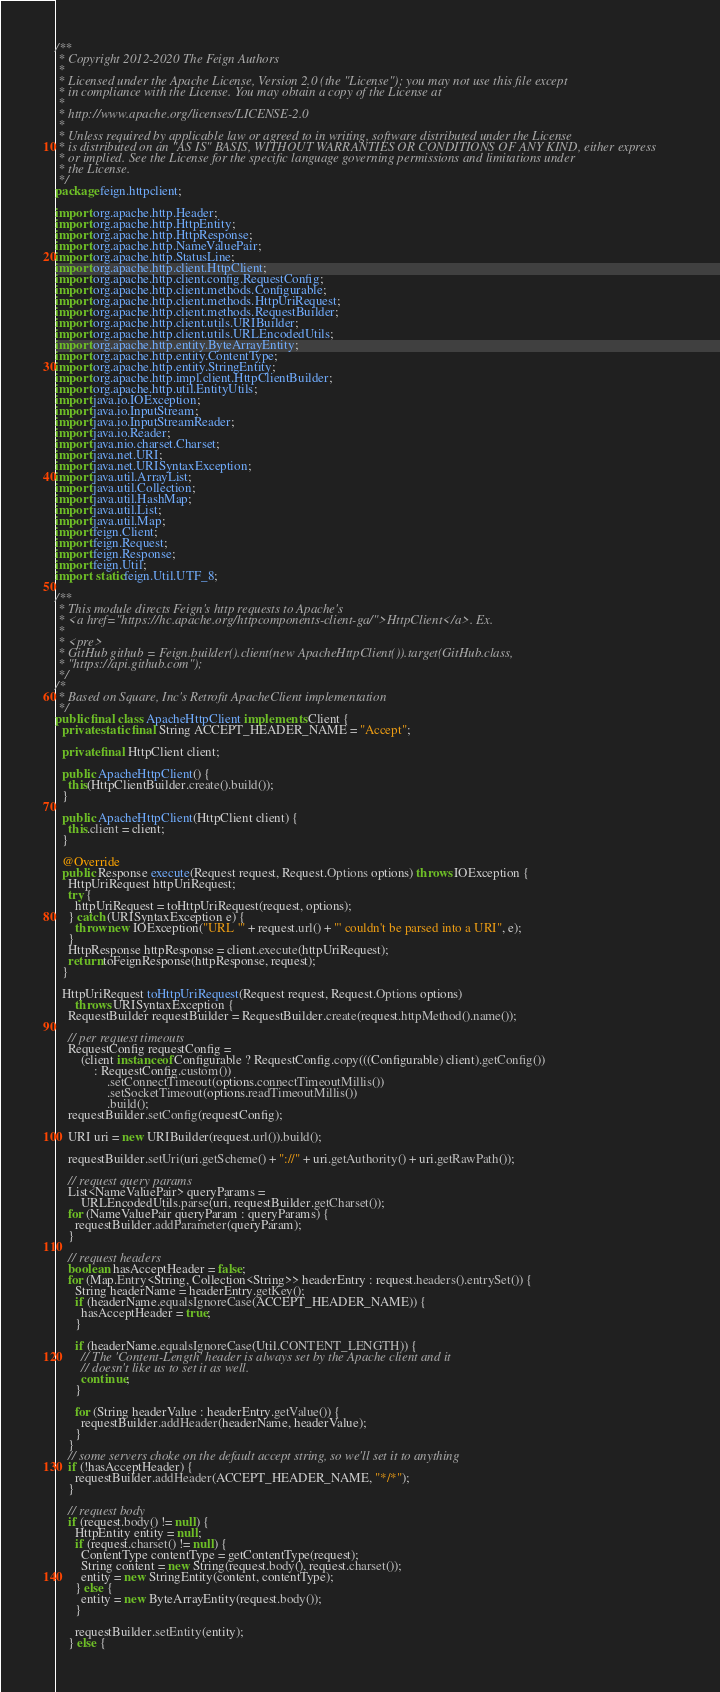<code> <loc_0><loc_0><loc_500><loc_500><_Java_>/**
 * Copyright 2012-2020 The Feign Authors
 *
 * Licensed under the Apache License, Version 2.0 (the "License"); you may not use this file except
 * in compliance with the License. You may obtain a copy of the License at
 *
 * http://www.apache.org/licenses/LICENSE-2.0
 *
 * Unless required by applicable law or agreed to in writing, software distributed under the License
 * is distributed on an "AS IS" BASIS, WITHOUT WARRANTIES OR CONDITIONS OF ANY KIND, either express
 * or implied. See the License for the specific language governing permissions and limitations under
 * the License.
 */
package feign.httpclient;

import org.apache.http.Header;
import org.apache.http.HttpEntity;
import org.apache.http.HttpResponse;
import org.apache.http.NameValuePair;
import org.apache.http.StatusLine;
import org.apache.http.client.HttpClient;
import org.apache.http.client.config.RequestConfig;
import org.apache.http.client.methods.Configurable;
import org.apache.http.client.methods.HttpUriRequest;
import org.apache.http.client.methods.RequestBuilder;
import org.apache.http.client.utils.URIBuilder;
import org.apache.http.client.utils.URLEncodedUtils;
import org.apache.http.entity.ByteArrayEntity;
import org.apache.http.entity.ContentType;
import org.apache.http.entity.StringEntity;
import org.apache.http.impl.client.HttpClientBuilder;
import org.apache.http.util.EntityUtils;
import java.io.IOException;
import java.io.InputStream;
import java.io.InputStreamReader;
import java.io.Reader;
import java.nio.charset.Charset;
import java.net.URI;
import java.net.URISyntaxException;
import java.util.ArrayList;
import java.util.Collection;
import java.util.HashMap;
import java.util.List;
import java.util.Map;
import feign.Client;
import feign.Request;
import feign.Response;
import feign.Util;
import static feign.Util.UTF_8;

/**
 * This module directs Feign's http requests to Apache's
 * <a href="https://hc.apache.org/httpcomponents-client-ga/">HttpClient</a>. Ex.
 *
 * <pre>
 * GitHub github = Feign.builder().client(new ApacheHttpClient()).target(GitHub.class,
 * "https://api.github.com");
 */
/*
 * Based on Square, Inc's Retrofit ApacheClient implementation
 */
public final class ApacheHttpClient implements Client {
  private static final String ACCEPT_HEADER_NAME = "Accept";

  private final HttpClient client;

  public ApacheHttpClient() {
    this(HttpClientBuilder.create().build());
  }

  public ApacheHttpClient(HttpClient client) {
    this.client = client;
  }

  @Override
  public Response execute(Request request, Request.Options options) throws IOException {
    HttpUriRequest httpUriRequest;
    try {
      httpUriRequest = toHttpUriRequest(request, options);
    } catch (URISyntaxException e) {
      throw new IOException("URL '" + request.url() + "' couldn't be parsed into a URI", e);
    }
    HttpResponse httpResponse = client.execute(httpUriRequest);
    return toFeignResponse(httpResponse, request);
  }

  HttpUriRequest toHttpUriRequest(Request request, Request.Options options)
      throws URISyntaxException {
    RequestBuilder requestBuilder = RequestBuilder.create(request.httpMethod().name());

    // per request timeouts
    RequestConfig requestConfig =
        (client instanceof Configurable ? RequestConfig.copy(((Configurable) client).getConfig())
            : RequestConfig.custom())
                .setConnectTimeout(options.connectTimeoutMillis())
                .setSocketTimeout(options.readTimeoutMillis())
                .build();
    requestBuilder.setConfig(requestConfig);

    URI uri = new URIBuilder(request.url()).build();

    requestBuilder.setUri(uri.getScheme() + "://" + uri.getAuthority() + uri.getRawPath());

    // request query params
    List<NameValuePair> queryParams =
        URLEncodedUtils.parse(uri, requestBuilder.getCharset());
    for (NameValuePair queryParam : queryParams) {
      requestBuilder.addParameter(queryParam);
    }

    // request headers
    boolean hasAcceptHeader = false;
    for (Map.Entry<String, Collection<String>> headerEntry : request.headers().entrySet()) {
      String headerName = headerEntry.getKey();
      if (headerName.equalsIgnoreCase(ACCEPT_HEADER_NAME)) {
        hasAcceptHeader = true;
      }

      if (headerName.equalsIgnoreCase(Util.CONTENT_LENGTH)) {
        // The 'Content-Length' header is always set by the Apache client and it
        // doesn't like us to set it as well.
        continue;
      }

      for (String headerValue : headerEntry.getValue()) {
        requestBuilder.addHeader(headerName, headerValue);
      }
    }
    // some servers choke on the default accept string, so we'll set it to anything
    if (!hasAcceptHeader) {
      requestBuilder.addHeader(ACCEPT_HEADER_NAME, "*/*");
    }

    // request body
    if (request.body() != null) {
      HttpEntity entity = null;
      if (request.charset() != null) {
        ContentType contentType = getContentType(request);
        String content = new String(request.body(), request.charset());
        entity = new StringEntity(content, contentType);
      } else {
        entity = new ByteArrayEntity(request.body());
      }

      requestBuilder.setEntity(entity);
    } else {</code> 